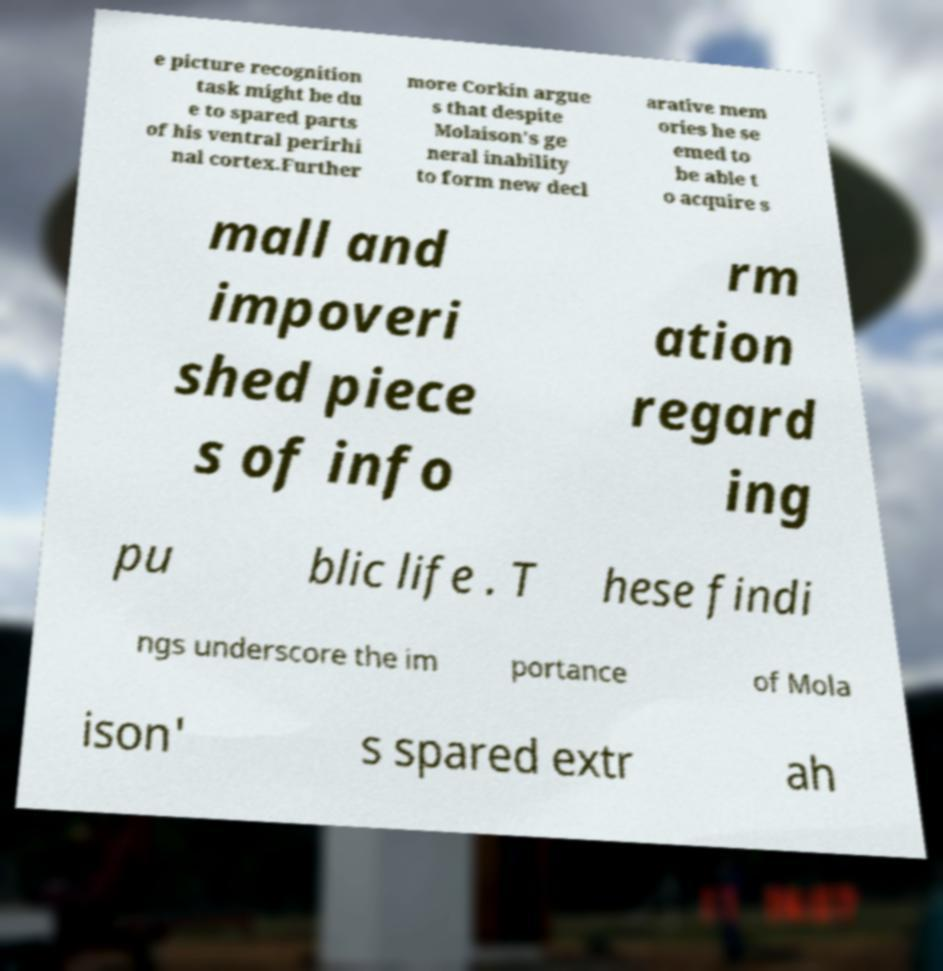For documentation purposes, I need the text within this image transcribed. Could you provide that? e picture recognition task might be du e to spared parts of his ventral perirhi nal cortex.Further more Corkin argue s that despite Molaison's ge neral inability to form new decl arative mem ories he se emed to be able t o acquire s mall and impoveri shed piece s of info rm ation regard ing pu blic life . T hese findi ngs underscore the im portance of Mola ison' s spared extr ah 